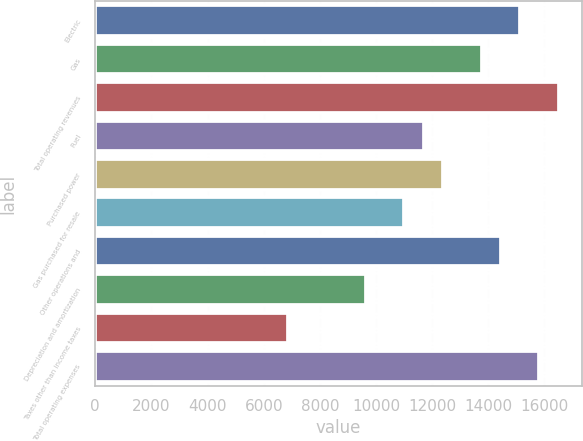Convert chart to OTSL. <chart><loc_0><loc_0><loc_500><loc_500><bar_chart><fcel>Electric<fcel>Gas<fcel>Total operating revenues<fcel>Fuel<fcel>Purchased power<fcel>Gas purchased for resale<fcel>Other operations and<fcel>Depreciation and amortization<fcel>Taxes other than income taxes<fcel>Total operating expenses<nl><fcel>15133<fcel>13757.5<fcel>16508.5<fcel>11694.3<fcel>12382<fcel>11006.5<fcel>14445.3<fcel>9631.04<fcel>6880.04<fcel>15820.8<nl></chart> 